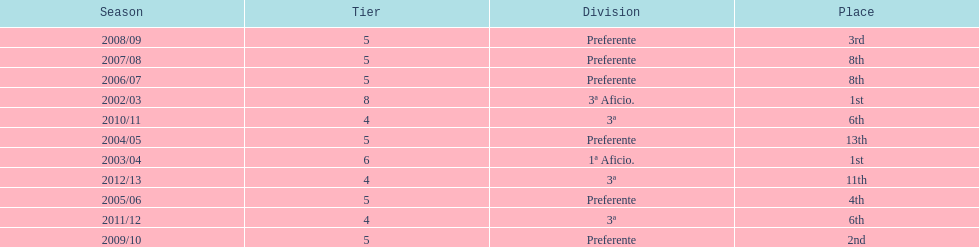How long did the team stay in first place? 2 years. 